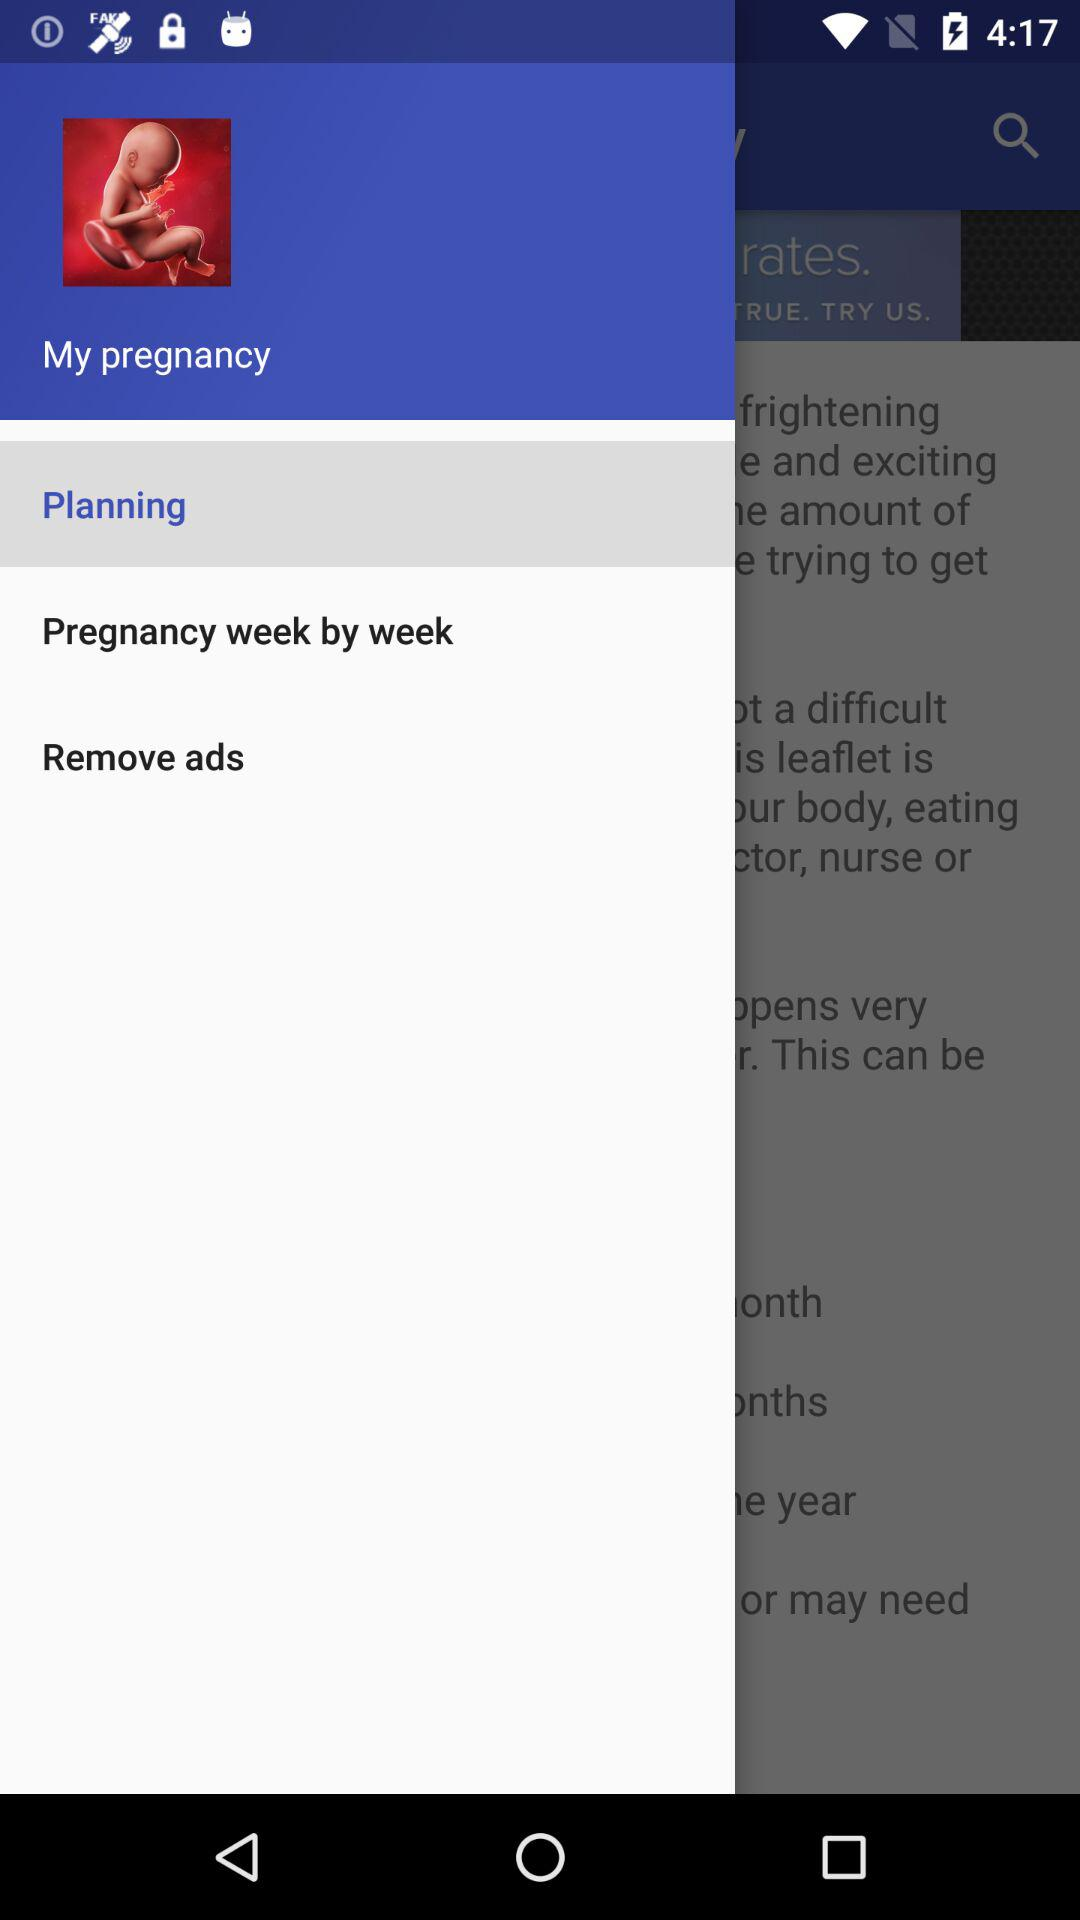What is the name of the application? The application name is "My pregnancy". 